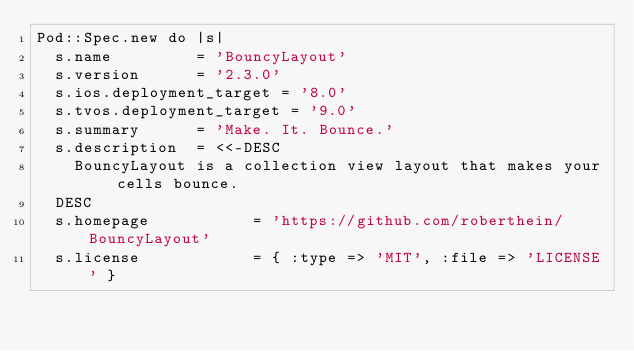Convert code to text. <code><loc_0><loc_0><loc_500><loc_500><_Ruby_>Pod::Spec.new do |s|
  s.name         = 'BouncyLayout'
  s.version      = '2.3.0'
  s.ios.deployment_target = '8.0'
  s.tvos.deployment_target = '9.0'
  s.summary      = 'Make. It. Bounce.'
  s.description  = <<-DESC
    BouncyLayout is a collection view layout that makes your cells bounce.
  DESC
  s.homepage           = 'https://github.com/roberthein/BouncyLayout'
  s.license            = { :type => 'MIT', :file => 'LICENSE' }</code> 